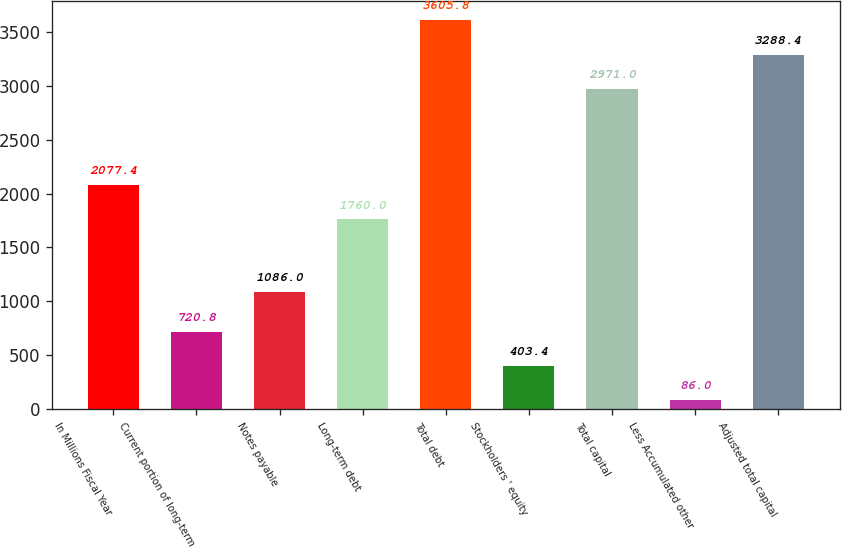Convert chart to OTSL. <chart><loc_0><loc_0><loc_500><loc_500><bar_chart><fcel>In Millions Fiscal Year<fcel>Current portion of long-term<fcel>Notes payable<fcel>Long-term debt<fcel>Total debt<fcel>Stockholders ' equity<fcel>Total capital<fcel>Less Accumulated other<fcel>Adjusted total capital<nl><fcel>2077.4<fcel>720.8<fcel>1086<fcel>1760<fcel>3605.8<fcel>403.4<fcel>2971<fcel>86<fcel>3288.4<nl></chart> 